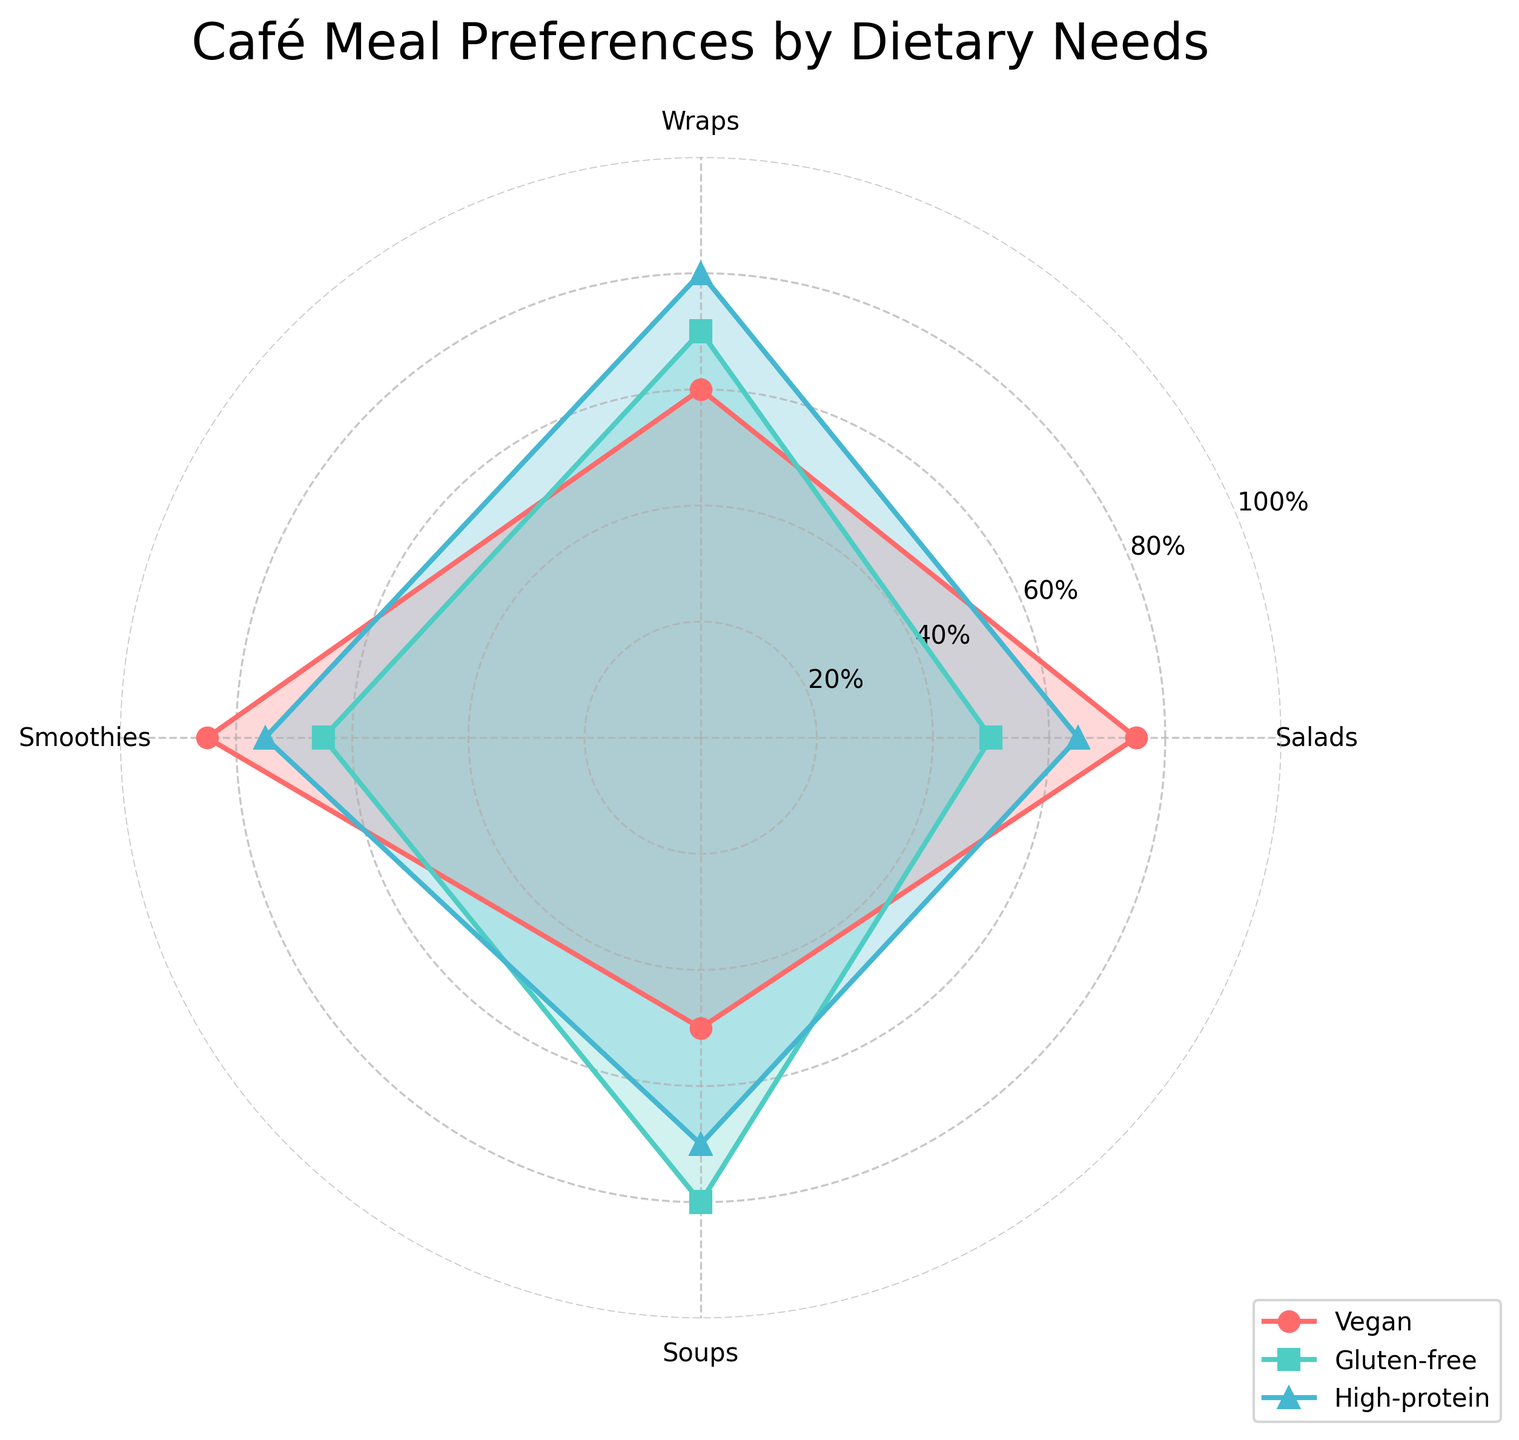What title is displayed at the top of the radar chart? The title of a radar chart is typically displayed at the top center of the figure. In this case, from the generated plot, the title should read "Café Meal Preferences by Dietary Needs".
Answer: Café Meal Preferences by Dietary Needs Which dietary need has the highest value for Smoothies? To determine which dietary need has the highest value for Smoothies, we look at the data points for Smoothies in the radar chart and compare them. Vegan has 85, Gluten-free has 65, and High-protein has 75. Therefore, Vegan has the highest value for Smoothies.
Answer: Vegan What is the difference between the highest and lowest values for Soups? The highest value for Soups is for Gluten-free (80), and the lowest value is for Vegan (50). The difference is calculated by subtracting the lowest value from the highest value: 80 - 50 = 30.
Answer: 30 Compare the preference for Wraps between Vegan and High-protein. Which one is higher and by how much? The value for Wraps for Vegan is 60, and for High-protein, it is 80. High-protein is higher by the difference between the two values: 80 - 60 = 20.
Answer: High-protein by 20 How many dietary needs are compared in the radar chart? The radar chart compares three dietary needs: Vegan, Gluten-free, and High-protein. These are visible in the figure’s legend.
Answer: 3 Which dietary need shows the least preference for Salads? The values for Salads are compared among the dietary needs. Vegan has 75, Gluten-free has 50, and High-protein has 65. Therefore, Gluten-free shows the least preference.
Answer: Gluten-free What is the average preference value for Soups across all dietary needs? The preference values for Soups are: Vegan (50), Gluten-free (80), and High-protein (70). Average is calculated as (50 + 80 + 70) / 3 = 200 / 3 ≈ 66.67.
Answer: ≈ 66.67 Identify the dietary need with the highest overall preference scores across all food categories (Salads, Wraps, Smoothies, Soups). To determine the dietary need with the highest overall preference, sum the values for each dietary need:
- Vegan: 75 + 60 + 85 + 50 = 270
- Gluten-free: 50 + 70 + 65 + 80 = 265
- High-protein: 65 + 80 + 75 + 70 = 290
High-protein has the highest overall preference scores.
Answer: High-protein 